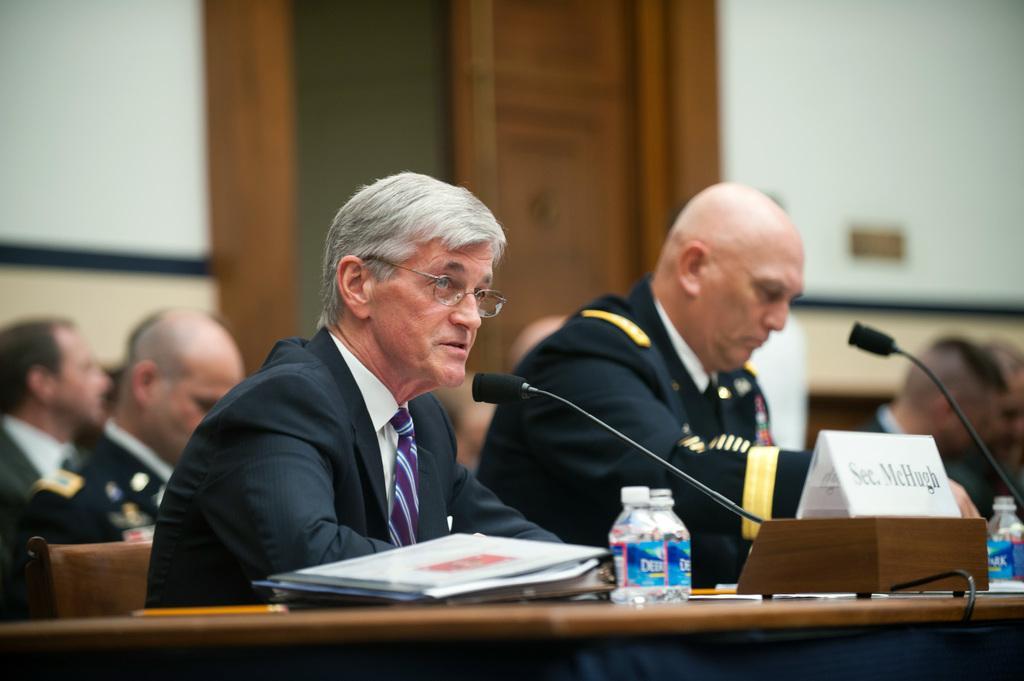Can you describe this image briefly? In this image I can see group of people sitting, the person in front is wearing black blazer, white shirt and purple color tie, and I can see few papers, bottles, microphones on the table. Background I can see a door in brown color and the wall is in white color. 